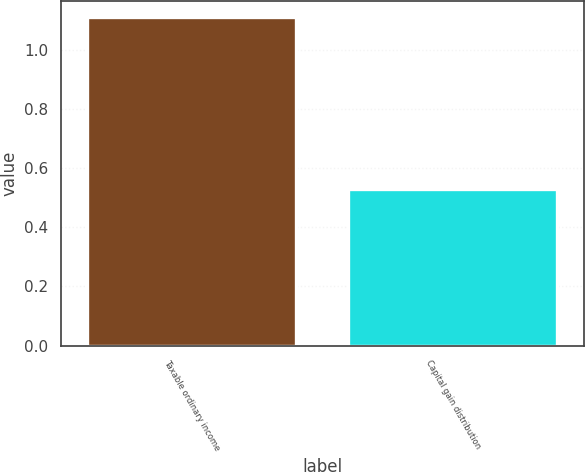<chart> <loc_0><loc_0><loc_500><loc_500><bar_chart><fcel>Taxable ordinary income<fcel>Capital gain distribution<nl><fcel>1.11<fcel>0.53<nl></chart> 